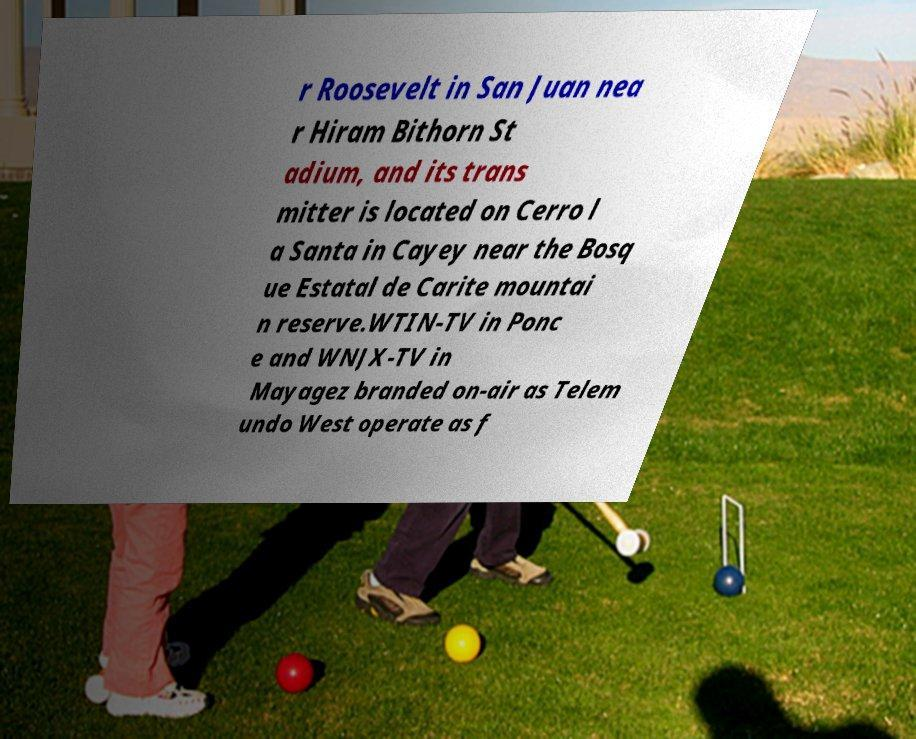Can you read and provide the text displayed in the image?This photo seems to have some interesting text. Can you extract and type it out for me? r Roosevelt in San Juan nea r Hiram Bithorn St adium, and its trans mitter is located on Cerro l a Santa in Cayey near the Bosq ue Estatal de Carite mountai n reserve.WTIN-TV in Ponc e and WNJX-TV in Mayagez branded on-air as Telem undo West operate as f 